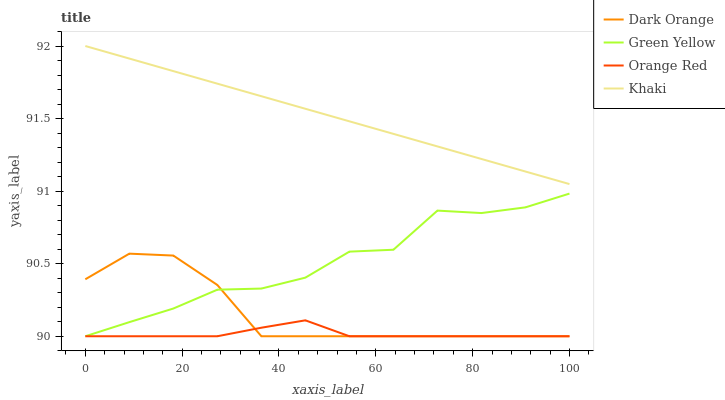Does Orange Red have the minimum area under the curve?
Answer yes or no. Yes. Does Khaki have the maximum area under the curve?
Answer yes or no. Yes. Does Green Yellow have the minimum area under the curve?
Answer yes or no. No. Does Green Yellow have the maximum area under the curve?
Answer yes or no. No. Is Khaki the smoothest?
Answer yes or no. Yes. Is Green Yellow the roughest?
Answer yes or no. Yes. Is Green Yellow the smoothest?
Answer yes or no. No. Is Khaki the roughest?
Answer yes or no. No. Does Dark Orange have the lowest value?
Answer yes or no. Yes. Does Khaki have the lowest value?
Answer yes or no. No. Does Khaki have the highest value?
Answer yes or no. Yes. Does Green Yellow have the highest value?
Answer yes or no. No. Is Orange Red less than Khaki?
Answer yes or no. Yes. Is Khaki greater than Dark Orange?
Answer yes or no. Yes. Does Dark Orange intersect Green Yellow?
Answer yes or no. Yes. Is Dark Orange less than Green Yellow?
Answer yes or no. No. Is Dark Orange greater than Green Yellow?
Answer yes or no. No. Does Orange Red intersect Khaki?
Answer yes or no. No. 